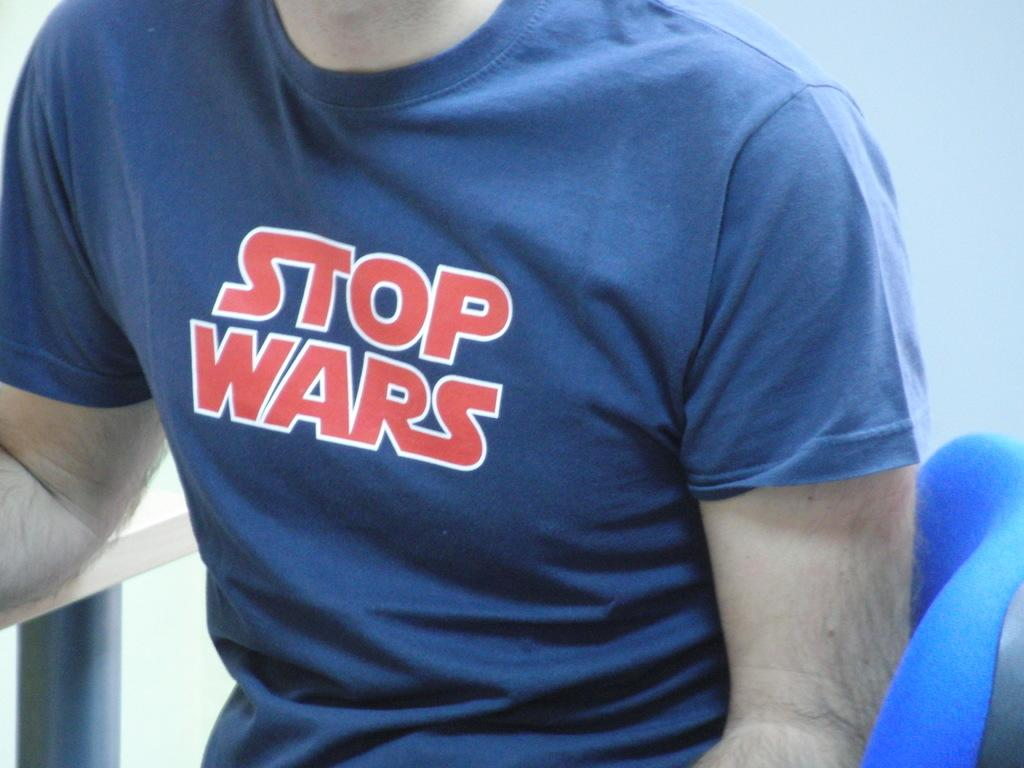<image>
Give a short and clear explanation of the subsequent image. the name stop wars that is on a shirt 